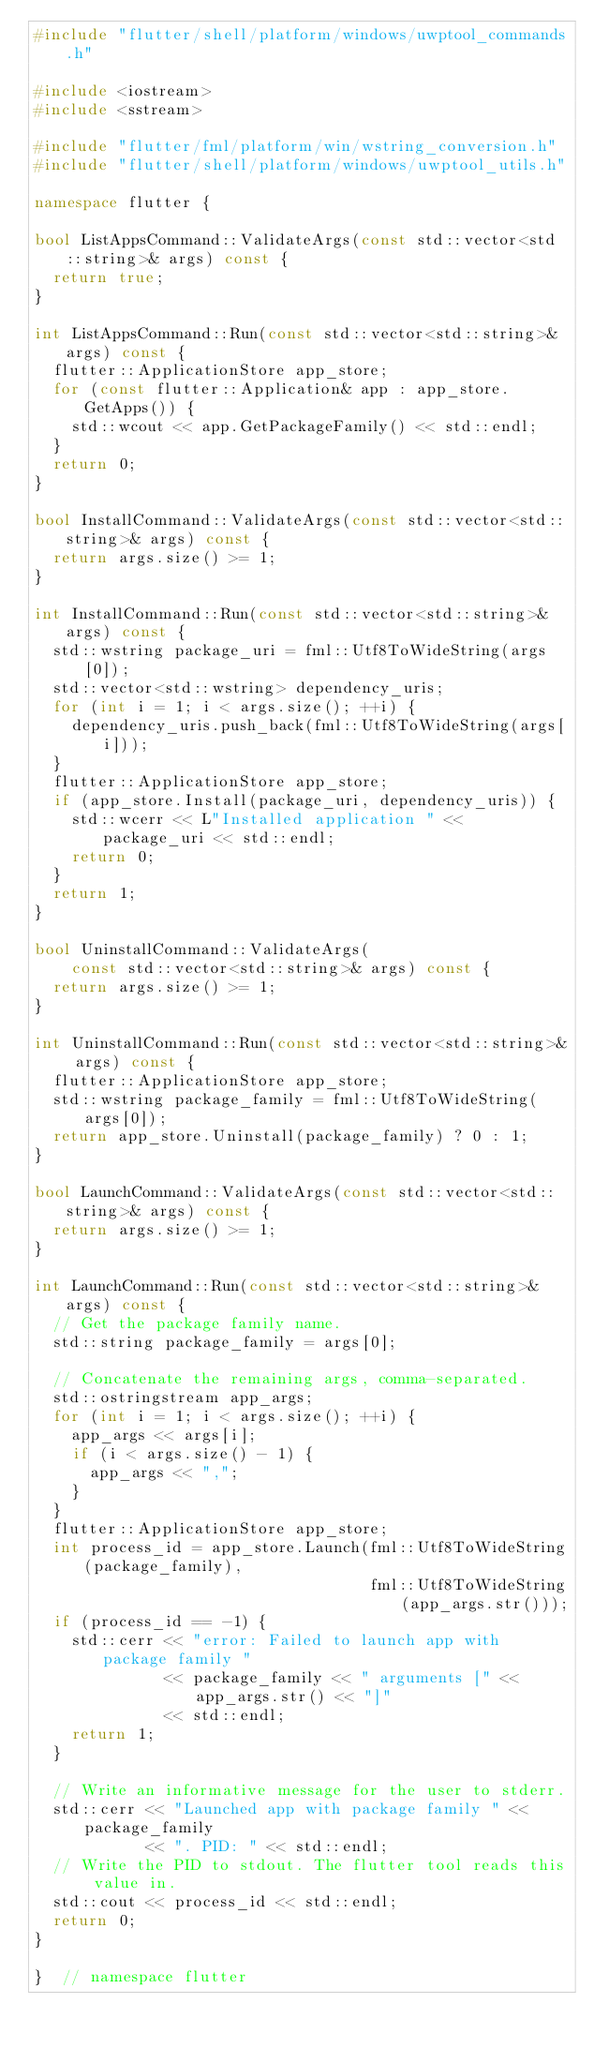<code> <loc_0><loc_0><loc_500><loc_500><_C++_>#include "flutter/shell/platform/windows/uwptool_commands.h"

#include <iostream>
#include <sstream>

#include "flutter/fml/platform/win/wstring_conversion.h"
#include "flutter/shell/platform/windows/uwptool_utils.h"

namespace flutter {

bool ListAppsCommand::ValidateArgs(const std::vector<std::string>& args) const {
  return true;
}

int ListAppsCommand::Run(const std::vector<std::string>& args) const {
  flutter::ApplicationStore app_store;
  for (const flutter::Application& app : app_store.GetApps()) {
    std::wcout << app.GetPackageFamily() << std::endl;
  }
  return 0;
}

bool InstallCommand::ValidateArgs(const std::vector<std::string>& args) const {
  return args.size() >= 1;
}

int InstallCommand::Run(const std::vector<std::string>& args) const {
  std::wstring package_uri = fml::Utf8ToWideString(args[0]);
  std::vector<std::wstring> dependency_uris;
  for (int i = 1; i < args.size(); ++i) {
    dependency_uris.push_back(fml::Utf8ToWideString(args[i]));
  }
  flutter::ApplicationStore app_store;
  if (app_store.Install(package_uri, dependency_uris)) {
    std::wcerr << L"Installed application " << package_uri << std::endl;
    return 0;
  }
  return 1;
}

bool UninstallCommand::ValidateArgs(
    const std::vector<std::string>& args) const {
  return args.size() >= 1;
}

int UninstallCommand::Run(const std::vector<std::string>& args) const {
  flutter::ApplicationStore app_store;
  std::wstring package_family = fml::Utf8ToWideString(args[0]);
  return app_store.Uninstall(package_family) ? 0 : 1;
}

bool LaunchCommand::ValidateArgs(const std::vector<std::string>& args) const {
  return args.size() >= 1;
}

int LaunchCommand::Run(const std::vector<std::string>& args) const {
  // Get the package family name.
  std::string package_family = args[0];

  // Concatenate the remaining args, comma-separated.
  std::ostringstream app_args;
  for (int i = 1; i < args.size(); ++i) {
    app_args << args[i];
    if (i < args.size() - 1) {
      app_args << ",";
    }
  }
  flutter::ApplicationStore app_store;
  int process_id = app_store.Launch(fml::Utf8ToWideString(package_family),
                                    fml::Utf8ToWideString(app_args.str()));
  if (process_id == -1) {
    std::cerr << "error: Failed to launch app with package family "
              << package_family << " arguments [" << app_args.str() << "]"
              << std::endl;
    return 1;
  }

  // Write an informative message for the user to stderr.
  std::cerr << "Launched app with package family " << package_family
            << ". PID: " << std::endl;
  // Write the PID to stdout. The flutter tool reads this value in.
  std::cout << process_id << std::endl;
  return 0;
}

}  // namespace flutter
</code> 